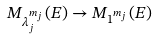Convert formula to latex. <formula><loc_0><loc_0><loc_500><loc_500>M _ { \lambda _ { j } ^ { m _ { j } } } ( E ) \to M _ { 1 ^ { m _ { j } } } ( E )</formula> 